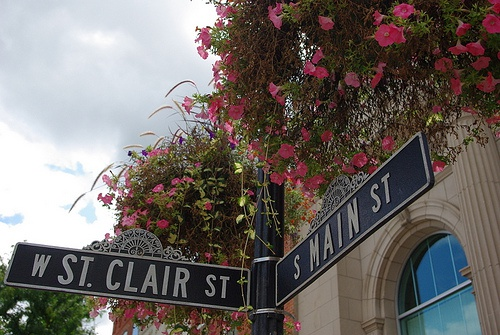Describe the objects in this image and their specific colors. I can see potted plant in lightgray, black, maroon, darkgreen, and gray tones and potted plant in lightgray, black, darkgreen, maroon, and gray tones in this image. 